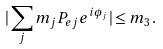<formula> <loc_0><loc_0><loc_500><loc_500>| \sum _ { j } m _ { j } P _ { e j } e ^ { i \phi _ { j } } | \leq m _ { 3 } \, .</formula> 